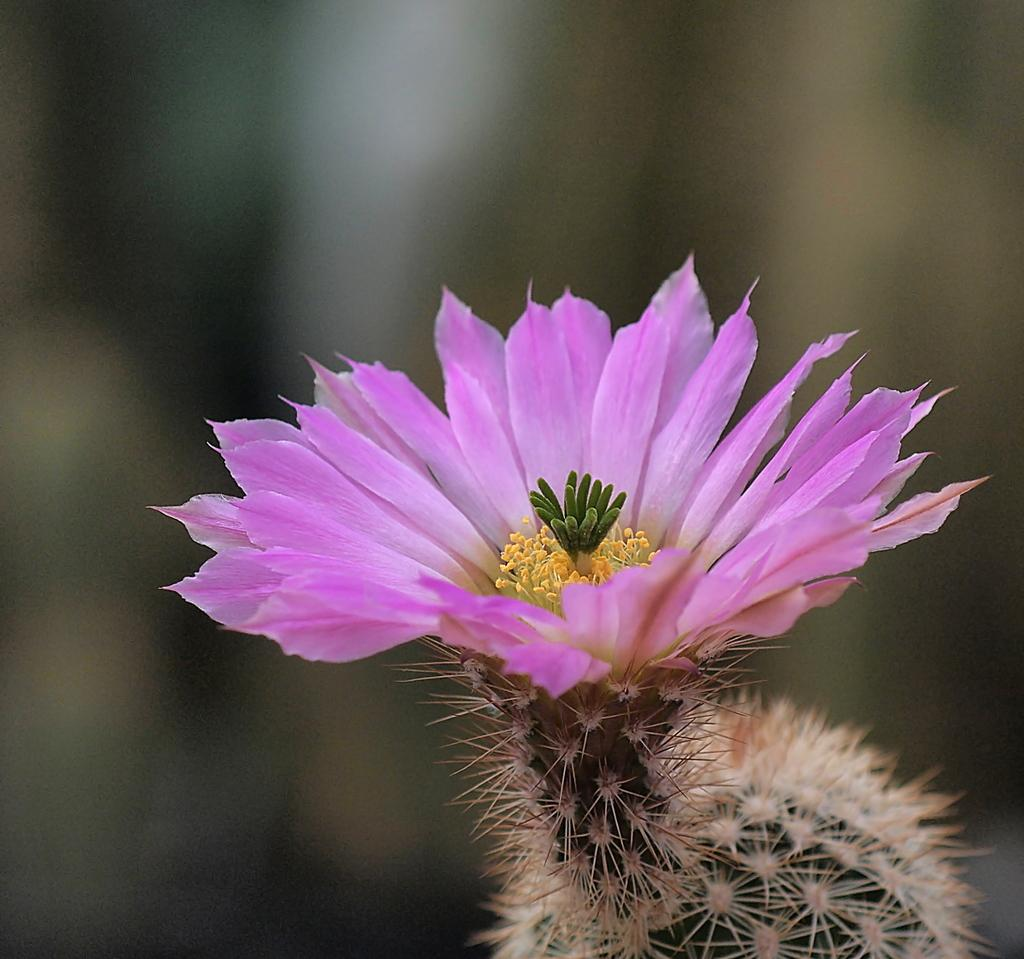What type of plant is visible in the image? There is a flower in the image. Can you describe the other plant in the image? There is a plant at the bottom of the image. What can be observed about the background of the image? The background of the image is blurred. What type of help is being provided to the flower in the image? There is no indication in the image that the flower is receiving any help. What type of operation is being performed on the plant in the image? There is no operation being performed on the plant in the image. 